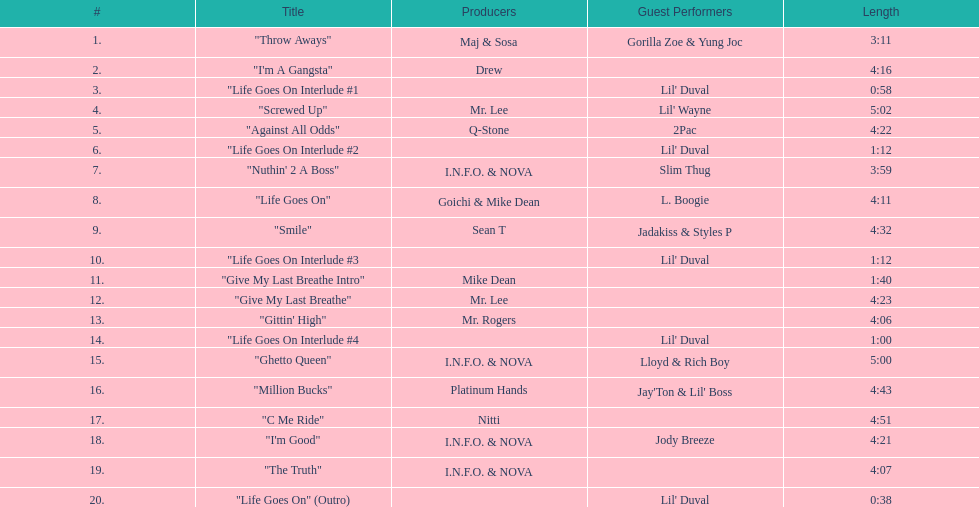How many tracks on trae's album "life goes on"? 20. 